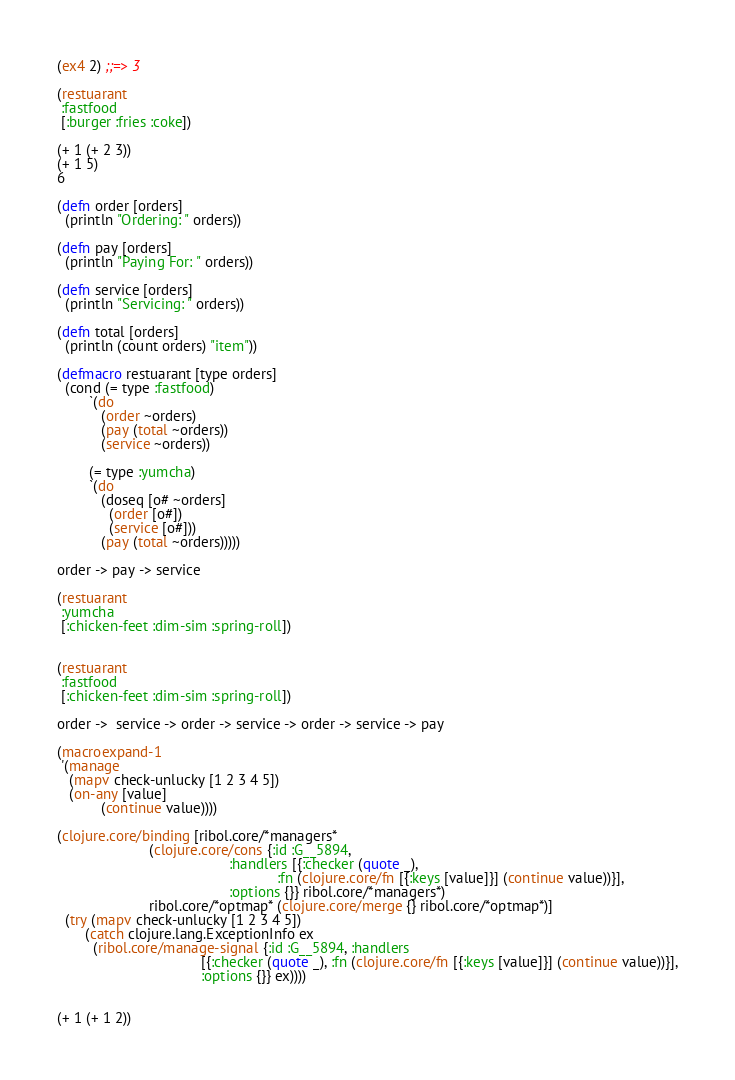Convert code to text. <code><loc_0><loc_0><loc_500><loc_500><_Clojure_>
(ex4 2) ;;=> 3

(restuarant
 :fastfood
 [:burger :fries :coke])

(+ 1 (+ 2 3))
(+ 1 5)
6

(defn order [orders]
  (println "Ordering: " orders))

(defn pay [orders]
  (println "Paying For: " orders))

(defn service [orders]
  (println "Servicing: " orders))

(defn total [orders]
  (println (count orders) "item"))

(defmacro restuarant [type orders]
  (cond (= type :fastfood)
        `(do
           (order ~orders)
           (pay (total ~orders))
           (service ~orders))

        (= type :yumcha)
        `(do
           (doseq [o# ~orders]
             (order [o#])
             (service [o#]))
           (pay (total ~orders)))))

order -> pay -> service

(restuarant
 :yumcha
 [:chicken-feet :dim-sim :spring-roll])


(restuarant
 :fastfood
 [:chicken-feet :dim-sim :spring-roll])

order ->  service -> order -> service -> order -> service -> pay

(macroexpand-1
 '(manage
   (mapv check-unlucky [1 2 3 4 5])
   (on-any [value]
           (continue value))))

(clojure.core/binding [ribol.core/*managers*
                       (clojure.core/cons {:id :G__5894,
                                           :handlers [{:checker (quote _),
                                                       :fn (clojure.core/fn [{:keys [value]}] (continue value))}],
                                           :options {}} ribol.core/*managers*)
                       ribol.core/*optmap* (clojure.core/merge {} ribol.core/*optmap*)]
  (try (mapv check-unlucky [1 2 3 4 5])
       (catch clojure.lang.ExceptionInfo ex
         (ribol.core/manage-signal {:id :G__5894, :handlers
                                    [{:checker (quote _), :fn (clojure.core/fn [{:keys [value]}] (continue value))}],
                                    :options {}} ex))))


(+ 1 (+ 1 2))</code> 